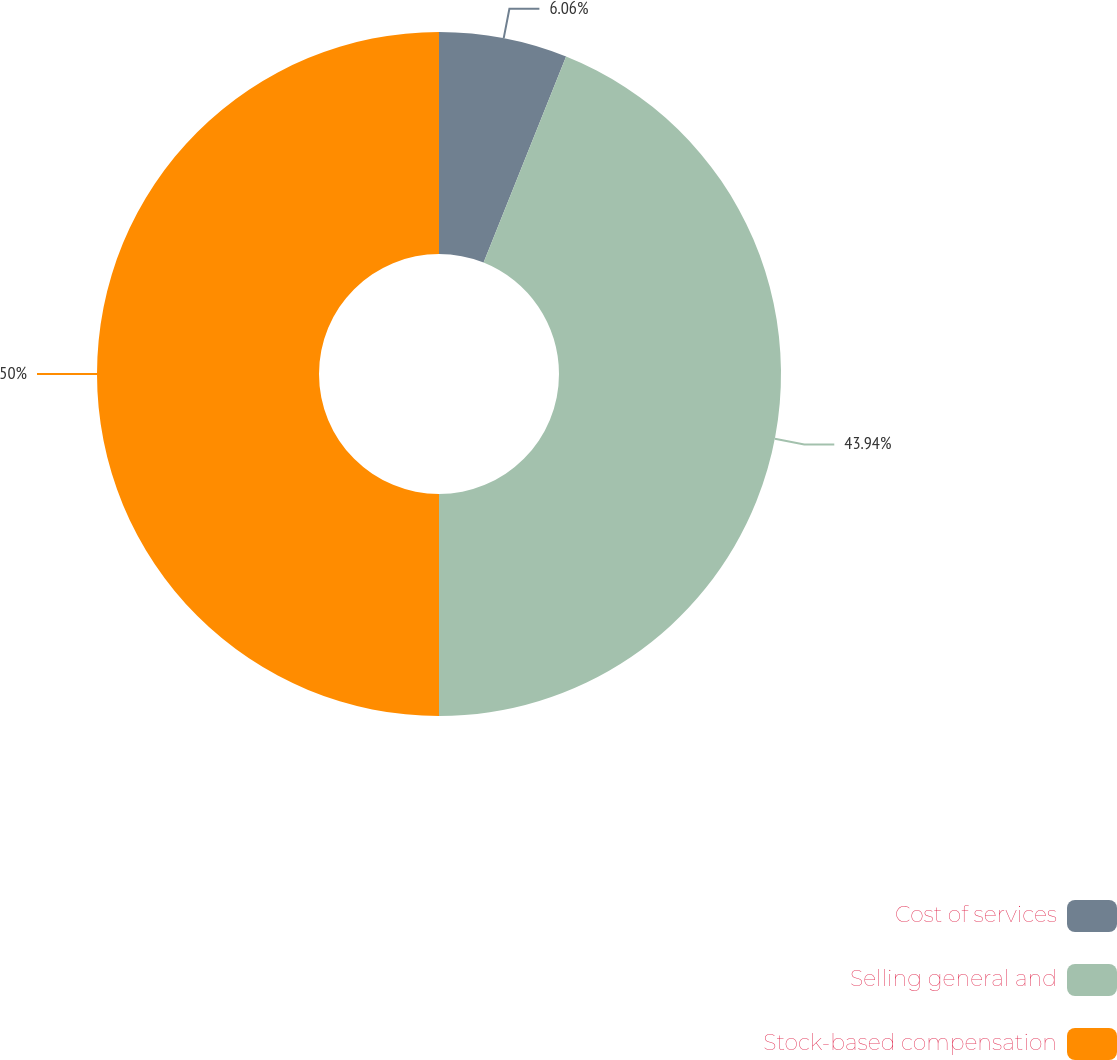Convert chart to OTSL. <chart><loc_0><loc_0><loc_500><loc_500><pie_chart><fcel>Cost of services<fcel>Selling general and<fcel>Stock-based compensation<nl><fcel>6.06%<fcel>43.94%<fcel>50.0%<nl></chart> 